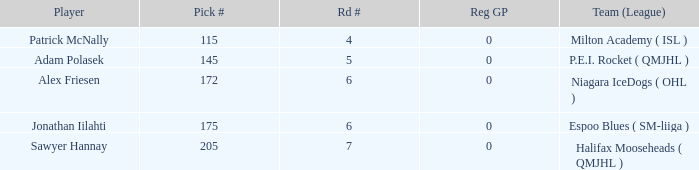What's sawyer hannay's total pick number? 1.0. 